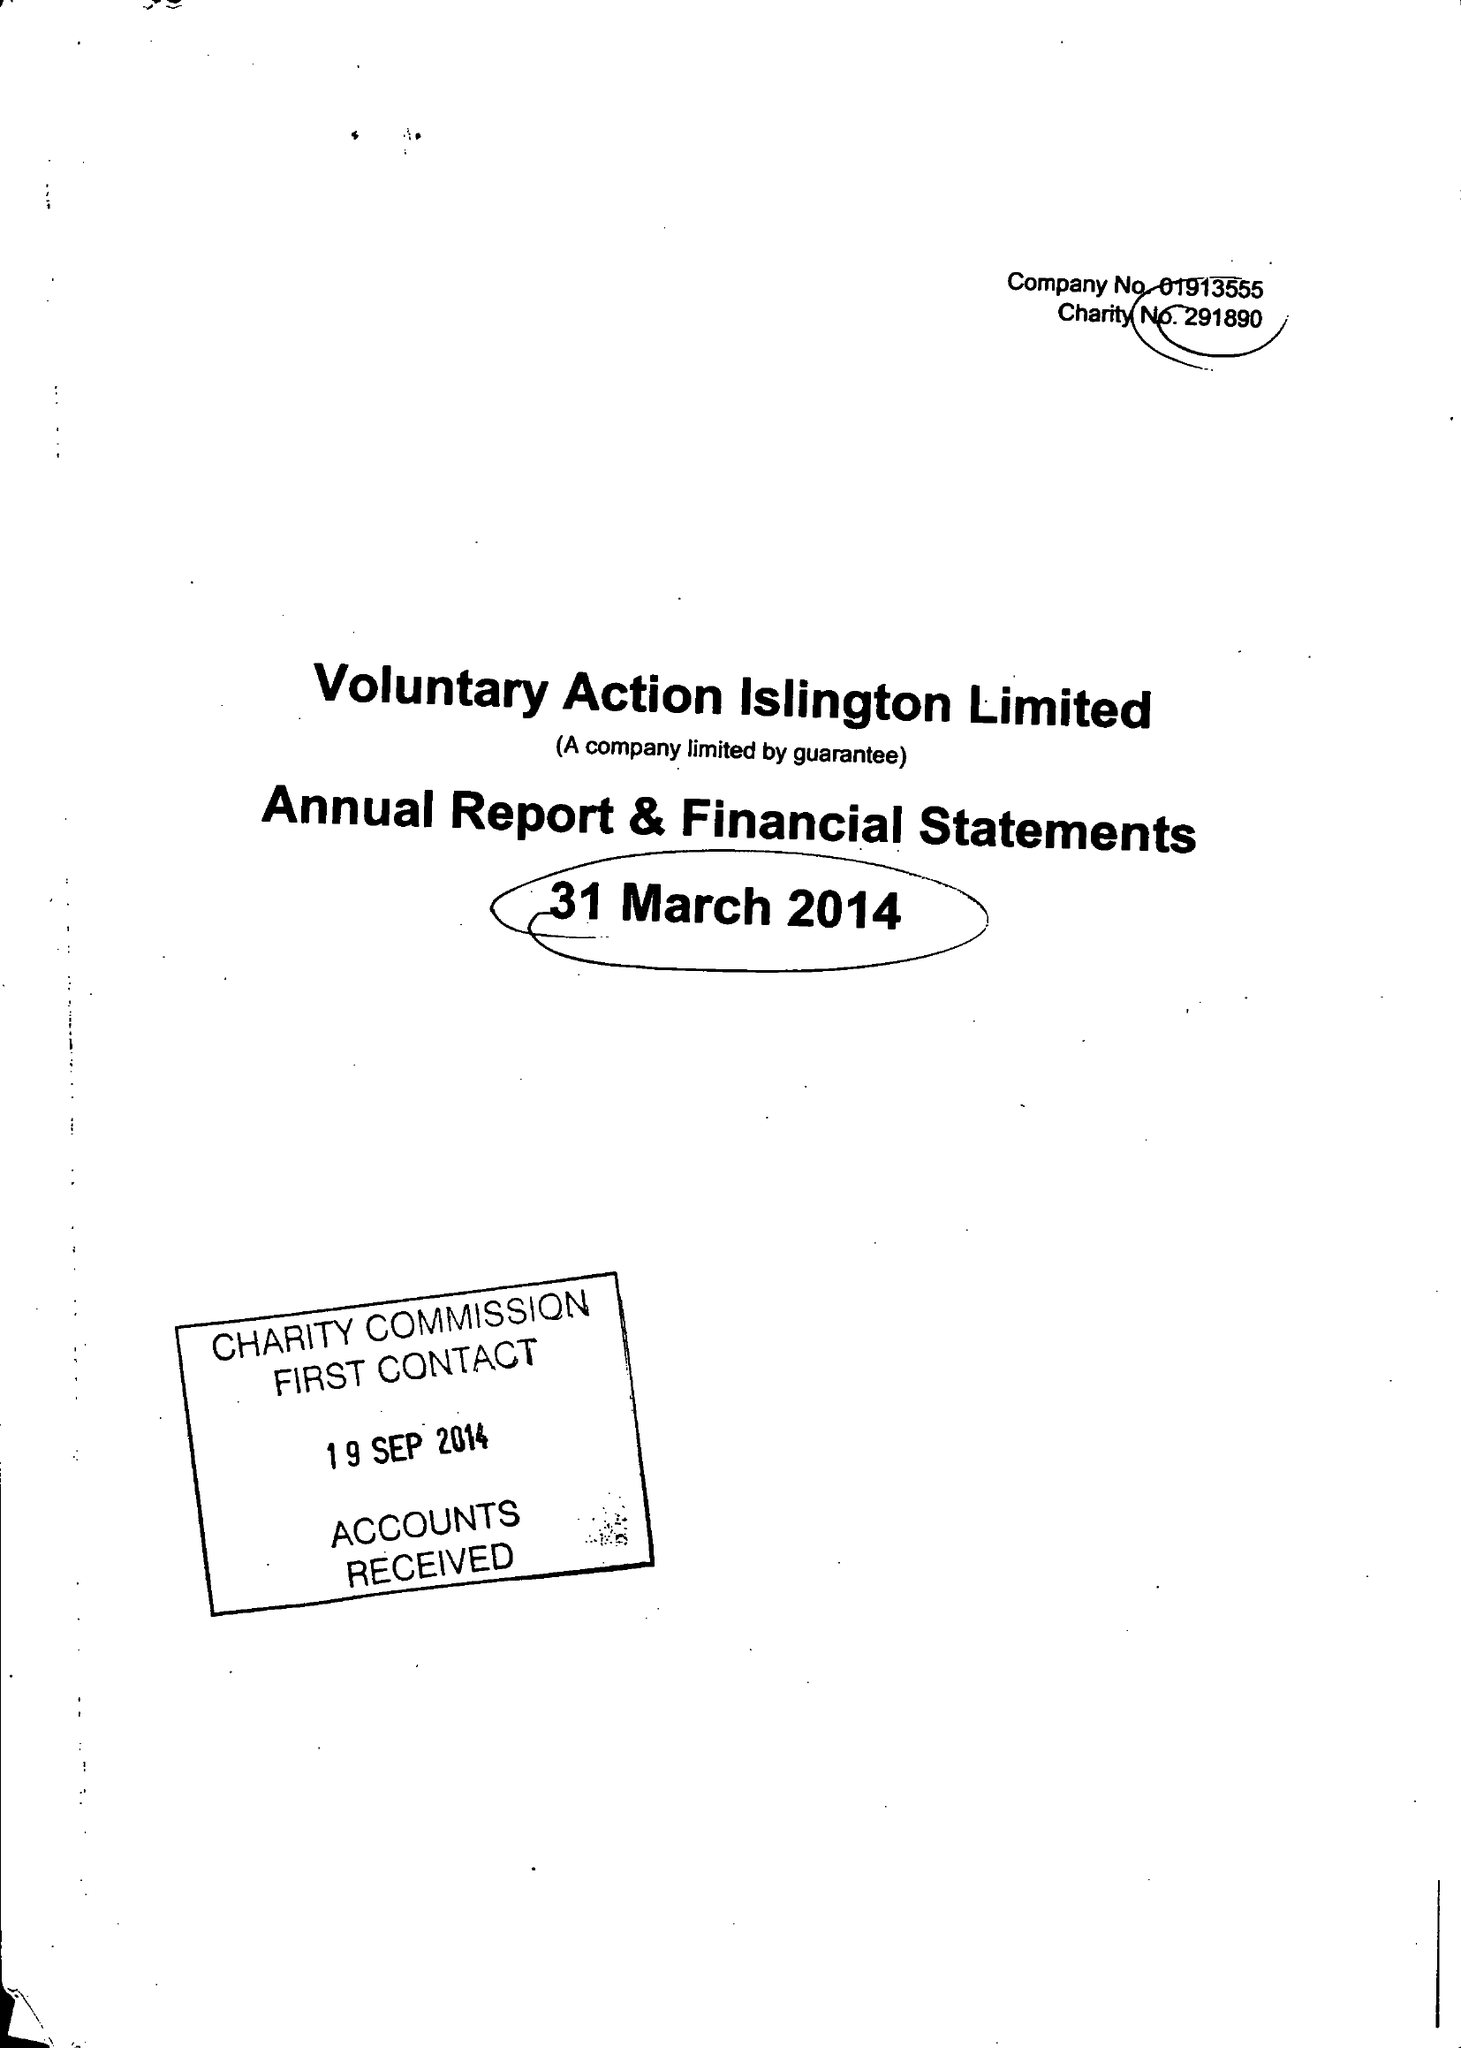What is the value for the charity_name?
Answer the question using a single word or phrase. Voluntary Action Islington Ltd. 